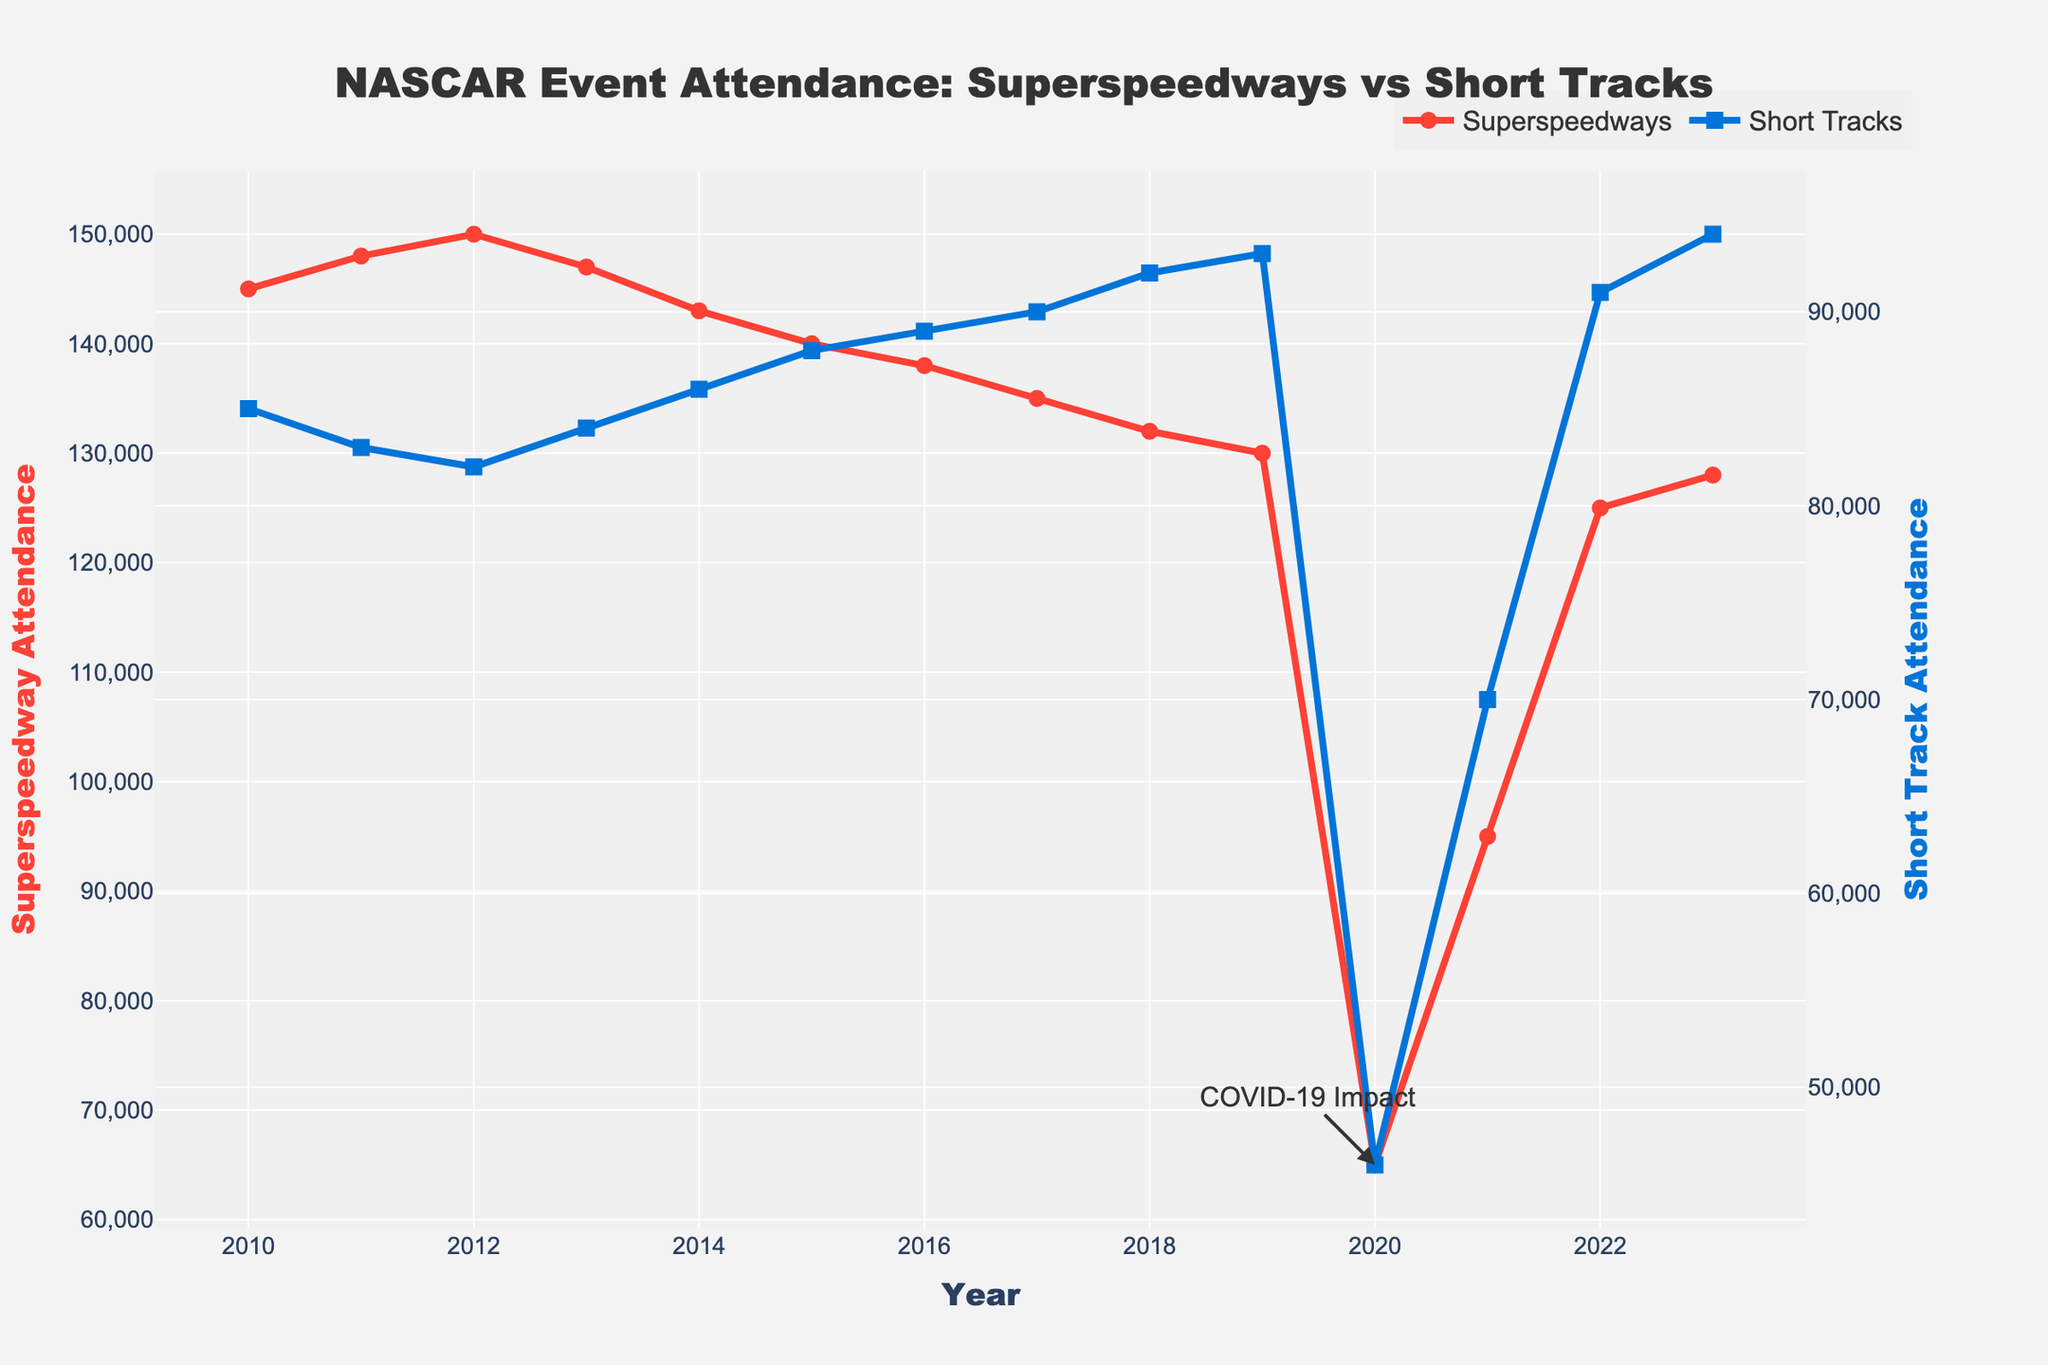What year had the highest attendance figure for Short Tracks? The highest attendance figure for Short Tracks is 94,000 in 2023. By scanning through the 'Short Tracks' data for each year, we can identify that 2023 has the highest figure.
Answer: 2023 Compare the attendance figures for Superspeedways and Short Tracks in 2020. Which one was higher? In 2020, the attendance for Superspeedways was 65,000, and for Short Tracks, it was 46,000. By comparing these numbers, 65,000 (Superspeedways) is greater than 46,000 (Short Tracks).
Answer: Superspeedways What is the overall trend in attendance for Superspeedways from 2010 to 2023? Observing the trend line for Superspeedways: It starts at 145,000 in 2010, gradually declines to a low of 65,000 in 2020 due to COVID-19, then rises again to 128,000 in 2023. Overall, it's a decreasing trend with a dip in 2020 and some recovery afterward.
Answer: Decreasing During which year did both Superspeedways and Short Tracks experience a significant drop in attendance? Both Superspeedways and Short Tracks experienced a significant drop in attendance in the year 2020, as highlighted by the annotation "COVID-19 Impact" in the plot.
Answer: 2020 What is the difference in attendance figures between Superspeedways and Short Tracks in 2022? In 2022, Superspeedways had an attendance of 125,000, and Short Tracks had 91,000. The difference is 125,000 - 91,000 = 34,000.
Answer: 34,000 Which year shows a higher attendance for Short Tracks compared to Superspeedways for the first time? By examining the figures, for the first time, Short Tracks had higher attendance than Superspeedways in 2021, when Short Tracks had 70,000 and Superspeedways had 95,000.
Answer: 2021 What is the average attendance for Superspeedways from 2010 to 2015? The attendance figures for Superspeedways from 2010 to 2015 are 145,000, 148,000, 150,000, 147,000, 143,000, and 140,000 respectively. Calculating the average: (145,000 + 148,000 + 150,000 + 147,000 + 143,000 + 140,000) / 6 = 145,500.
Answer: 145,500 In what year did Short Tracks achieve exactly 90,000 in attendance? Looking through the Short Tracks data, in 2017, the attendance was 90,000.
Answer: 2017 